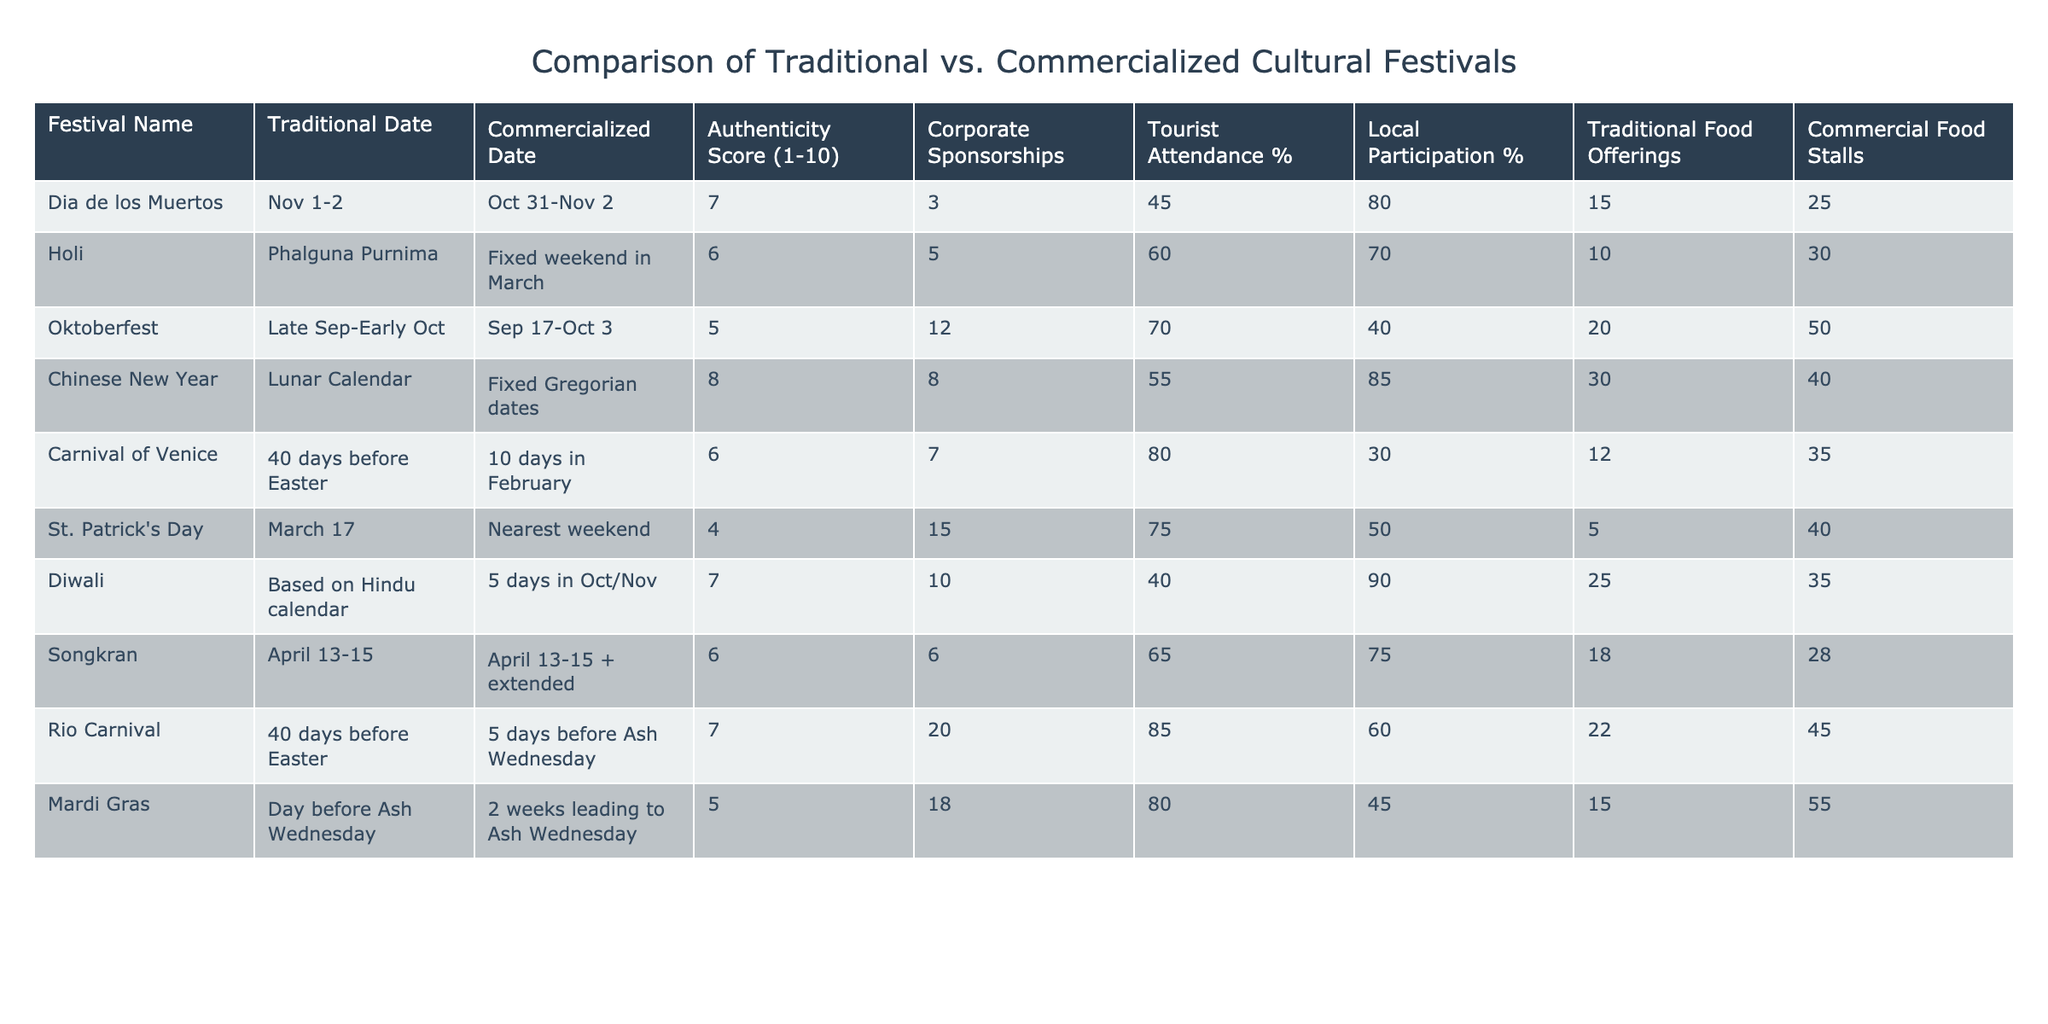What's the authenticity score of Holi? The authenticity score of Holi is mentioned directly in the table under the "Authenticity Score (1-10)" column for Holi, which is 6.
Answer: 6 What percentage of tourist attendance is recorded for the Rio Carnival? The table lists the percentage of tourist attendance for the Rio Carnival under "Tourist Attendance %", which shows 85%.
Answer: 85% How many corporate sponsorships does the Carnival of Venice have? The number of corporate sponsorships is shown in the table under "Corporate Sponsorships" for the Carnival of Venice, indicating there are 7.
Answer: 7 What is the average authenticity score of the festivals listed? To find the average authenticity score, sum the scores (7+6+5+8+6+4+7+6+7+5) = 57 and divide by the number of festivals (10), which gives an average of 5.7.
Answer: 5.7 Is the percentage of local participation higher for Dia de los Muertos or Carnival of Venice? The table indicates local participation percentages: Dia de los Muertos at 80% and Carnival of Venice at 30%. Comparing these values shows that 80% is higher than 30%.
Answer: Yes Which festival has the highest percentage of local participation? By examining the "Local Participation %" column, we find Diwali with 90%, which is the highest among all festivals listed.
Answer: Diwali What is the difference in the number of commercial food stalls between Oktoberfest and St. Patrick's Day? The number of commercial food stalls for Oktoberfest is 50 and for St. Patrick's Day is 40. The difference is calculated as 50 - 40 = 10.
Answer: 10 Which festival has the least corporate sponsorships and what is its score? By reviewing the "Corporate Sponsorships" column, St. Patrick's Day records 15, which is the least. Its authenticity score is listed as 4.
Answer: St. Patrick's Day with a score of 4 If we compare traditional food offerings of Diwali and Songkran, which festival offers more? Diwali offers 25 traditional food offerings, while Songkran offers 18. Therefore, Diwali has more traditional food offerings than Songkran.
Answer: Diwali Which festival has a higher percentage of tourist attendance, Dia de los Muertos or Mardi Gras? Dia de los Muertos has a tourist attendance percentage of 45%, while Mardi Gras has 80%. Since 80% is higher than 45%, Mardi Gras has a higher percentage.
Answer: Mardi Gras 